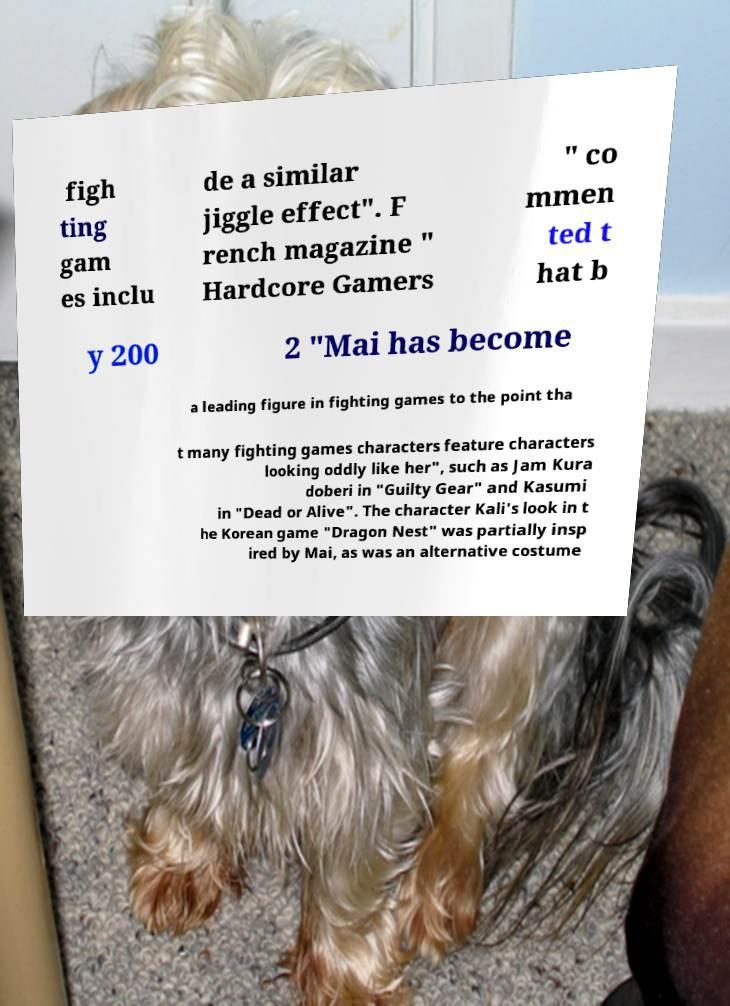I need the written content from this picture converted into text. Can you do that? figh ting gam es inclu de a similar jiggle effect". F rench magazine " Hardcore Gamers " co mmen ted t hat b y 200 2 "Mai has become a leading figure in fighting games to the point tha t many fighting games characters feature characters looking oddly like her", such as Jam Kura doberi in "Guilty Gear" and Kasumi in "Dead or Alive". The character Kali's look in t he Korean game "Dragon Nest" was partially insp ired by Mai, as was an alternative costume 